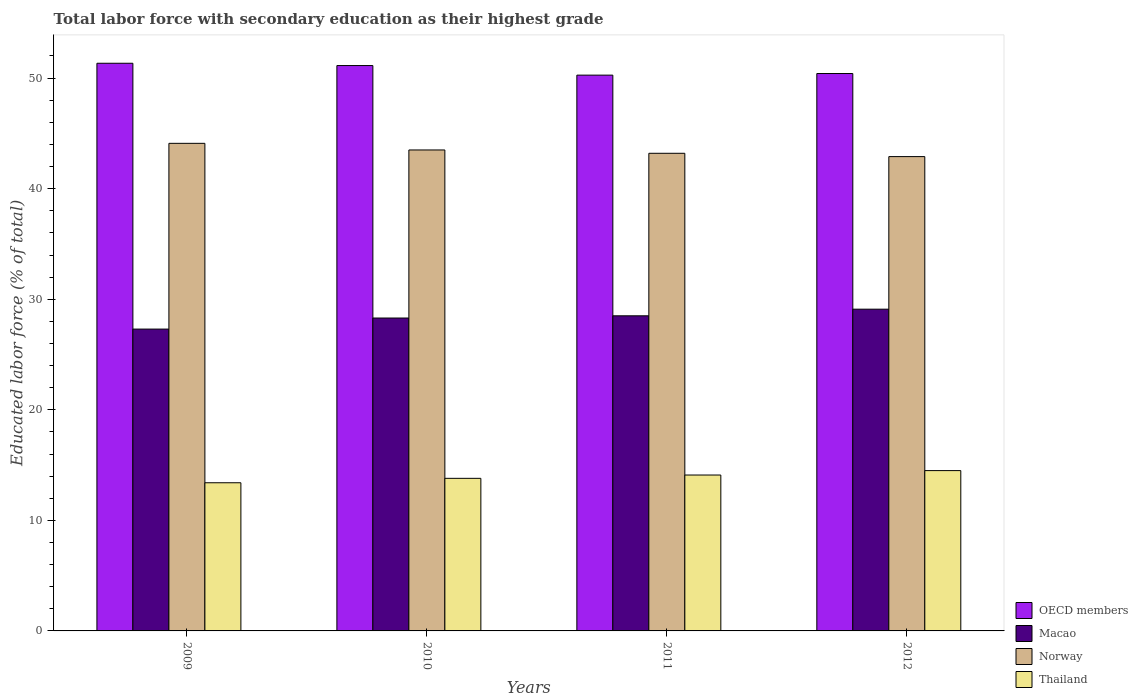How many different coloured bars are there?
Make the answer very short. 4. How many groups of bars are there?
Make the answer very short. 4. Are the number of bars per tick equal to the number of legend labels?
Offer a terse response. Yes. Are the number of bars on each tick of the X-axis equal?
Your answer should be very brief. Yes. How many bars are there on the 3rd tick from the left?
Keep it short and to the point. 4. What is the label of the 2nd group of bars from the left?
Your response must be concise. 2010. In how many cases, is the number of bars for a given year not equal to the number of legend labels?
Keep it short and to the point. 0. What is the percentage of total labor force with primary education in Thailand in 2009?
Keep it short and to the point. 13.4. Across all years, what is the maximum percentage of total labor force with primary education in Macao?
Offer a very short reply. 29.1. Across all years, what is the minimum percentage of total labor force with primary education in Norway?
Ensure brevity in your answer.  42.9. In which year was the percentage of total labor force with primary education in OECD members maximum?
Offer a terse response. 2009. What is the total percentage of total labor force with primary education in Macao in the graph?
Ensure brevity in your answer.  113.2. What is the difference between the percentage of total labor force with primary education in Thailand in 2009 and that in 2010?
Make the answer very short. -0.4. What is the difference between the percentage of total labor force with primary education in Thailand in 2010 and the percentage of total labor force with primary education in Macao in 2012?
Keep it short and to the point. -15.3. What is the average percentage of total labor force with primary education in Thailand per year?
Your answer should be compact. 13.95. In the year 2012, what is the difference between the percentage of total labor force with primary education in Macao and percentage of total labor force with primary education in Thailand?
Offer a very short reply. 14.6. What is the ratio of the percentage of total labor force with primary education in Macao in 2011 to that in 2012?
Give a very brief answer. 0.98. Is the percentage of total labor force with primary education in Macao in 2010 less than that in 2012?
Make the answer very short. Yes. Is the difference between the percentage of total labor force with primary education in Macao in 2009 and 2011 greater than the difference between the percentage of total labor force with primary education in Thailand in 2009 and 2011?
Your answer should be compact. No. What is the difference between the highest and the second highest percentage of total labor force with primary education in Thailand?
Ensure brevity in your answer.  0.4. What is the difference between the highest and the lowest percentage of total labor force with primary education in Norway?
Keep it short and to the point. 1.2. In how many years, is the percentage of total labor force with primary education in OECD members greater than the average percentage of total labor force with primary education in OECD members taken over all years?
Keep it short and to the point. 2. Is it the case that in every year, the sum of the percentage of total labor force with primary education in Macao and percentage of total labor force with primary education in Thailand is greater than the sum of percentage of total labor force with primary education in OECD members and percentage of total labor force with primary education in Norway?
Offer a terse response. Yes. Is it the case that in every year, the sum of the percentage of total labor force with primary education in Thailand and percentage of total labor force with primary education in OECD members is greater than the percentage of total labor force with primary education in Macao?
Ensure brevity in your answer.  Yes. How many bars are there?
Keep it short and to the point. 16. Are all the bars in the graph horizontal?
Make the answer very short. No. What is the difference between two consecutive major ticks on the Y-axis?
Provide a succinct answer. 10. Are the values on the major ticks of Y-axis written in scientific E-notation?
Your answer should be very brief. No. Does the graph contain any zero values?
Provide a succinct answer. No. Does the graph contain grids?
Offer a terse response. No. Where does the legend appear in the graph?
Offer a very short reply. Bottom right. How many legend labels are there?
Give a very brief answer. 4. How are the legend labels stacked?
Offer a very short reply. Vertical. What is the title of the graph?
Make the answer very short. Total labor force with secondary education as their highest grade. What is the label or title of the Y-axis?
Keep it short and to the point. Educated labor force (% of total). What is the Educated labor force (% of total) in OECD members in 2009?
Your answer should be compact. 51.34. What is the Educated labor force (% of total) in Macao in 2009?
Provide a short and direct response. 27.3. What is the Educated labor force (% of total) in Norway in 2009?
Provide a succinct answer. 44.1. What is the Educated labor force (% of total) of Thailand in 2009?
Your response must be concise. 13.4. What is the Educated labor force (% of total) in OECD members in 2010?
Keep it short and to the point. 51.13. What is the Educated labor force (% of total) of Macao in 2010?
Offer a terse response. 28.3. What is the Educated labor force (% of total) in Norway in 2010?
Provide a succinct answer. 43.5. What is the Educated labor force (% of total) in Thailand in 2010?
Your answer should be very brief. 13.8. What is the Educated labor force (% of total) of OECD members in 2011?
Ensure brevity in your answer.  50.27. What is the Educated labor force (% of total) in Macao in 2011?
Your answer should be very brief. 28.5. What is the Educated labor force (% of total) in Norway in 2011?
Offer a terse response. 43.2. What is the Educated labor force (% of total) in Thailand in 2011?
Your answer should be very brief. 14.1. What is the Educated labor force (% of total) of OECD members in 2012?
Your answer should be compact. 50.41. What is the Educated labor force (% of total) of Macao in 2012?
Provide a succinct answer. 29.1. What is the Educated labor force (% of total) of Norway in 2012?
Your response must be concise. 42.9. What is the Educated labor force (% of total) of Thailand in 2012?
Give a very brief answer. 14.5. Across all years, what is the maximum Educated labor force (% of total) of OECD members?
Provide a succinct answer. 51.34. Across all years, what is the maximum Educated labor force (% of total) in Macao?
Make the answer very short. 29.1. Across all years, what is the maximum Educated labor force (% of total) of Norway?
Your answer should be compact. 44.1. Across all years, what is the maximum Educated labor force (% of total) in Thailand?
Provide a short and direct response. 14.5. Across all years, what is the minimum Educated labor force (% of total) in OECD members?
Provide a short and direct response. 50.27. Across all years, what is the minimum Educated labor force (% of total) in Macao?
Ensure brevity in your answer.  27.3. Across all years, what is the minimum Educated labor force (% of total) of Norway?
Your answer should be very brief. 42.9. Across all years, what is the minimum Educated labor force (% of total) of Thailand?
Offer a very short reply. 13.4. What is the total Educated labor force (% of total) of OECD members in the graph?
Make the answer very short. 203.16. What is the total Educated labor force (% of total) of Macao in the graph?
Provide a succinct answer. 113.2. What is the total Educated labor force (% of total) in Norway in the graph?
Ensure brevity in your answer.  173.7. What is the total Educated labor force (% of total) in Thailand in the graph?
Your answer should be compact. 55.8. What is the difference between the Educated labor force (% of total) in OECD members in 2009 and that in 2010?
Offer a very short reply. 0.21. What is the difference between the Educated labor force (% of total) in Norway in 2009 and that in 2010?
Provide a succinct answer. 0.6. What is the difference between the Educated labor force (% of total) in OECD members in 2009 and that in 2011?
Your answer should be compact. 1.07. What is the difference between the Educated labor force (% of total) of OECD members in 2009 and that in 2012?
Ensure brevity in your answer.  0.93. What is the difference between the Educated labor force (% of total) in Norway in 2009 and that in 2012?
Ensure brevity in your answer.  1.2. What is the difference between the Educated labor force (% of total) in Thailand in 2009 and that in 2012?
Give a very brief answer. -1.1. What is the difference between the Educated labor force (% of total) in OECD members in 2010 and that in 2011?
Offer a terse response. 0.87. What is the difference between the Educated labor force (% of total) in OECD members in 2010 and that in 2012?
Give a very brief answer. 0.72. What is the difference between the Educated labor force (% of total) in Thailand in 2010 and that in 2012?
Keep it short and to the point. -0.7. What is the difference between the Educated labor force (% of total) in OECD members in 2011 and that in 2012?
Make the answer very short. -0.15. What is the difference between the Educated labor force (% of total) of Norway in 2011 and that in 2012?
Your answer should be very brief. 0.3. What is the difference between the Educated labor force (% of total) in Thailand in 2011 and that in 2012?
Provide a short and direct response. -0.4. What is the difference between the Educated labor force (% of total) of OECD members in 2009 and the Educated labor force (% of total) of Macao in 2010?
Your response must be concise. 23.04. What is the difference between the Educated labor force (% of total) in OECD members in 2009 and the Educated labor force (% of total) in Norway in 2010?
Offer a very short reply. 7.84. What is the difference between the Educated labor force (% of total) in OECD members in 2009 and the Educated labor force (% of total) in Thailand in 2010?
Keep it short and to the point. 37.54. What is the difference between the Educated labor force (% of total) in Macao in 2009 and the Educated labor force (% of total) in Norway in 2010?
Make the answer very short. -16.2. What is the difference between the Educated labor force (% of total) of Norway in 2009 and the Educated labor force (% of total) of Thailand in 2010?
Ensure brevity in your answer.  30.3. What is the difference between the Educated labor force (% of total) of OECD members in 2009 and the Educated labor force (% of total) of Macao in 2011?
Your response must be concise. 22.84. What is the difference between the Educated labor force (% of total) in OECD members in 2009 and the Educated labor force (% of total) in Norway in 2011?
Your answer should be compact. 8.14. What is the difference between the Educated labor force (% of total) in OECD members in 2009 and the Educated labor force (% of total) in Thailand in 2011?
Offer a terse response. 37.24. What is the difference between the Educated labor force (% of total) in Macao in 2009 and the Educated labor force (% of total) in Norway in 2011?
Provide a short and direct response. -15.9. What is the difference between the Educated labor force (% of total) of Macao in 2009 and the Educated labor force (% of total) of Thailand in 2011?
Your answer should be very brief. 13.2. What is the difference between the Educated labor force (% of total) in OECD members in 2009 and the Educated labor force (% of total) in Macao in 2012?
Provide a succinct answer. 22.24. What is the difference between the Educated labor force (% of total) in OECD members in 2009 and the Educated labor force (% of total) in Norway in 2012?
Offer a very short reply. 8.44. What is the difference between the Educated labor force (% of total) of OECD members in 2009 and the Educated labor force (% of total) of Thailand in 2012?
Provide a succinct answer. 36.84. What is the difference between the Educated labor force (% of total) of Macao in 2009 and the Educated labor force (% of total) of Norway in 2012?
Offer a very short reply. -15.6. What is the difference between the Educated labor force (% of total) in Macao in 2009 and the Educated labor force (% of total) in Thailand in 2012?
Provide a succinct answer. 12.8. What is the difference between the Educated labor force (% of total) of Norway in 2009 and the Educated labor force (% of total) of Thailand in 2012?
Your answer should be very brief. 29.6. What is the difference between the Educated labor force (% of total) in OECD members in 2010 and the Educated labor force (% of total) in Macao in 2011?
Your answer should be compact. 22.63. What is the difference between the Educated labor force (% of total) in OECD members in 2010 and the Educated labor force (% of total) in Norway in 2011?
Ensure brevity in your answer.  7.93. What is the difference between the Educated labor force (% of total) in OECD members in 2010 and the Educated labor force (% of total) in Thailand in 2011?
Offer a terse response. 37.03. What is the difference between the Educated labor force (% of total) in Macao in 2010 and the Educated labor force (% of total) in Norway in 2011?
Your response must be concise. -14.9. What is the difference between the Educated labor force (% of total) in Macao in 2010 and the Educated labor force (% of total) in Thailand in 2011?
Ensure brevity in your answer.  14.2. What is the difference between the Educated labor force (% of total) of Norway in 2010 and the Educated labor force (% of total) of Thailand in 2011?
Provide a succinct answer. 29.4. What is the difference between the Educated labor force (% of total) in OECD members in 2010 and the Educated labor force (% of total) in Macao in 2012?
Provide a succinct answer. 22.03. What is the difference between the Educated labor force (% of total) in OECD members in 2010 and the Educated labor force (% of total) in Norway in 2012?
Offer a very short reply. 8.23. What is the difference between the Educated labor force (% of total) of OECD members in 2010 and the Educated labor force (% of total) of Thailand in 2012?
Provide a short and direct response. 36.63. What is the difference between the Educated labor force (% of total) of Macao in 2010 and the Educated labor force (% of total) of Norway in 2012?
Your answer should be compact. -14.6. What is the difference between the Educated labor force (% of total) in Macao in 2010 and the Educated labor force (% of total) in Thailand in 2012?
Your answer should be very brief. 13.8. What is the difference between the Educated labor force (% of total) of OECD members in 2011 and the Educated labor force (% of total) of Macao in 2012?
Provide a succinct answer. 21.17. What is the difference between the Educated labor force (% of total) of OECD members in 2011 and the Educated labor force (% of total) of Norway in 2012?
Offer a terse response. 7.37. What is the difference between the Educated labor force (% of total) in OECD members in 2011 and the Educated labor force (% of total) in Thailand in 2012?
Your response must be concise. 35.77. What is the difference between the Educated labor force (% of total) of Macao in 2011 and the Educated labor force (% of total) of Norway in 2012?
Give a very brief answer. -14.4. What is the difference between the Educated labor force (% of total) in Norway in 2011 and the Educated labor force (% of total) in Thailand in 2012?
Provide a succinct answer. 28.7. What is the average Educated labor force (% of total) in OECD members per year?
Make the answer very short. 50.79. What is the average Educated labor force (% of total) in Macao per year?
Make the answer very short. 28.3. What is the average Educated labor force (% of total) in Norway per year?
Make the answer very short. 43.42. What is the average Educated labor force (% of total) of Thailand per year?
Make the answer very short. 13.95. In the year 2009, what is the difference between the Educated labor force (% of total) of OECD members and Educated labor force (% of total) of Macao?
Your answer should be very brief. 24.04. In the year 2009, what is the difference between the Educated labor force (% of total) of OECD members and Educated labor force (% of total) of Norway?
Your answer should be compact. 7.24. In the year 2009, what is the difference between the Educated labor force (% of total) in OECD members and Educated labor force (% of total) in Thailand?
Ensure brevity in your answer.  37.94. In the year 2009, what is the difference between the Educated labor force (% of total) of Macao and Educated labor force (% of total) of Norway?
Offer a terse response. -16.8. In the year 2009, what is the difference between the Educated labor force (% of total) in Macao and Educated labor force (% of total) in Thailand?
Provide a short and direct response. 13.9. In the year 2009, what is the difference between the Educated labor force (% of total) in Norway and Educated labor force (% of total) in Thailand?
Provide a succinct answer. 30.7. In the year 2010, what is the difference between the Educated labor force (% of total) in OECD members and Educated labor force (% of total) in Macao?
Offer a terse response. 22.83. In the year 2010, what is the difference between the Educated labor force (% of total) in OECD members and Educated labor force (% of total) in Norway?
Keep it short and to the point. 7.63. In the year 2010, what is the difference between the Educated labor force (% of total) of OECD members and Educated labor force (% of total) of Thailand?
Make the answer very short. 37.33. In the year 2010, what is the difference between the Educated labor force (% of total) of Macao and Educated labor force (% of total) of Norway?
Make the answer very short. -15.2. In the year 2010, what is the difference between the Educated labor force (% of total) in Macao and Educated labor force (% of total) in Thailand?
Provide a short and direct response. 14.5. In the year 2010, what is the difference between the Educated labor force (% of total) in Norway and Educated labor force (% of total) in Thailand?
Offer a very short reply. 29.7. In the year 2011, what is the difference between the Educated labor force (% of total) in OECD members and Educated labor force (% of total) in Macao?
Make the answer very short. 21.77. In the year 2011, what is the difference between the Educated labor force (% of total) in OECD members and Educated labor force (% of total) in Norway?
Provide a succinct answer. 7.07. In the year 2011, what is the difference between the Educated labor force (% of total) of OECD members and Educated labor force (% of total) of Thailand?
Provide a short and direct response. 36.17. In the year 2011, what is the difference between the Educated labor force (% of total) in Macao and Educated labor force (% of total) in Norway?
Your answer should be very brief. -14.7. In the year 2011, what is the difference between the Educated labor force (% of total) of Macao and Educated labor force (% of total) of Thailand?
Your response must be concise. 14.4. In the year 2011, what is the difference between the Educated labor force (% of total) of Norway and Educated labor force (% of total) of Thailand?
Ensure brevity in your answer.  29.1. In the year 2012, what is the difference between the Educated labor force (% of total) of OECD members and Educated labor force (% of total) of Macao?
Your answer should be very brief. 21.31. In the year 2012, what is the difference between the Educated labor force (% of total) of OECD members and Educated labor force (% of total) of Norway?
Give a very brief answer. 7.51. In the year 2012, what is the difference between the Educated labor force (% of total) of OECD members and Educated labor force (% of total) of Thailand?
Provide a succinct answer. 35.91. In the year 2012, what is the difference between the Educated labor force (% of total) in Norway and Educated labor force (% of total) in Thailand?
Give a very brief answer. 28.4. What is the ratio of the Educated labor force (% of total) in Macao in 2009 to that in 2010?
Your answer should be very brief. 0.96. What is the ratio of the Educated labor force (% of total) of Norway in 2009 to that in 2010?
Keep it short and to the point. 1.01. What is the ratio of the Educated labor force (% of total) in Thailand in 2009 to that in 2010?
Provide a succinct answer. 0.97. What is the ratio of the Educated labor force (% of total) in OECD members in 2009 to that in 2011?
Provide a short and direct response. 1.02. What is the ratio of the Educated labor force (% of total) in Macao in 2009 to that in 2011?
Give a very brief answer. 0.96. What is the ratio of the Educated labor force (% of total) of Norway in 2009 to that in 2011?
Provide a succinct answer. 1.02. What is the ratio of the Educated labor force (% of total) of Thailand in 2009 to that in 2011?
Make the answer very short. 0.95. What is the ratio of the Educated labor force (% of total) of OECD members in 2009 to that in 2012?
Ensure brevity in your answer.  1.02. What is the ratio of the Educated labor force (% of total) in Macao in 2009 to that in 2012?
Ensure brevity in your answer.  0.94. What is the ratio of the Educated labor force (% of total) in Norway in 2009 to that in 2012?
Offer a terse response. 1.03. What is the ratio of the Educated labor force (% of total) of Thailand in 2009 to that in 2012?
Make the answer very short. 0.92. What is the ratio of the Educated labor force (% of total) of OECD members in 2010 to that in 2011?
Give a very brief answer. 1.02. What is the ratio of the Educated labor force (% of total) in Thailand in 2010 to that in 2011?
Your answer should be very brief. 0.98. What is the ratio of the Educated labor force (% of total) in OECD members in 2010 to that in 2012?
Keep it short and to the point. 1.01. What is the ratio of the Educated labor force (% of total) in Macao in 2010 to that in 2012?
Offer a very short reply. 0.97. What is the ratio of the Educated labor force (% of total) in Thailand in 2010 to that in 2012?
Give a very brief answer. 0.95. What is the ratio of the Educated labor force (% of total) in OECD members in 2011 to that in 2012?
Give a very brief answer. 1. What is the ratio of the Educated labor force (% of total) in Macao in 2011 to that in 2012?
Your answer should be very brief. 0.98. What is the ratio of the Educated labor force (% of total) of Norway in 2011 to that in 2012?
Give a very brief answer. 1.01. What is the ratio of the Educated labor force (% of total) in Thailand in 2011 to that in 2012?
Provide a succinct answer. 0.97. What is the difference between the highest and the second highest Educated labor force (% of total) of OECD members?
Give a very brief answer. 0.21. What is the difference between the highest and the second highest Educated labor force (% of total) in Macao?
Your answer should be compact. 0.6. What is the difference between the highest and the second highest Educated labor force (% of total) in Norway?
Your response must be concise. 0.6. What is the difference between the highest and the second highest Educated labor force (% of total) of Thailand?
Provide a short and direct response. 0.4. What is the difference between the highest and the lowest Educated labor force (% of total) in OECD members?
Offer a very short reply. 1.07. What is the difference between the highest and the lowest Educated labor force (% of total) of Macao?
Your response must be concise. 1.8. What is the difference between the highest and the lowest Educated labor force (% of total) in Thailand?
Give a very brief answer. 1.1. 